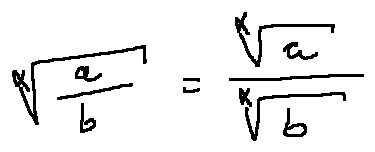<formula> <loc_0><loc_0><loc_500><loc_500>\sqrt { [ } x ] { \frac { a } { b } } = \frac { \sqrt { [ } x ] { a } } { \sqrt { [ } x ] { b } }</formula> 